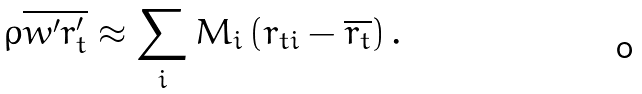Convert formula to latex. <formula><loc_0><loc_0><loc_500><loc_500>\rho \overline { w ^ { \prime } r _ { t } ^ { \prime } } \approx \sum _ { i } M _ { i } \left ( r _ { t i } - \overline { r _ { t } } \right ) .</formula> 